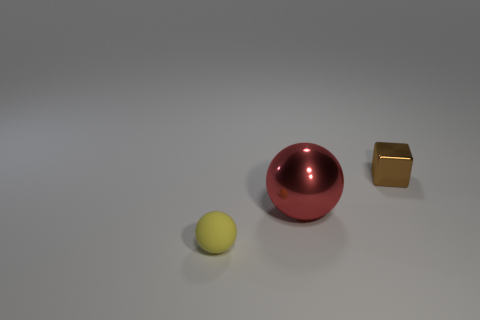Are there any shiny objects to the right of the sphere that is behind the tiny object in front of the red object?
Your response must be concise. Yes. What is the material of the large red object that is the same shape as the yellow thing?
Provide a short and direct response. Metal. There is a metallic thing that is right of the red thing; what color is it?
Provide a succinct answer. Brown. There is a red sphere; is it the same size as the object to the right of the big red shiny thing?
Make the answer very short. No. The small object to the left of the object that is on the right side of the ball to the right of the tiny yellow rubber thing is what color?
Your answer should be compact. Yellow. Is the material of the tiny thing that is behind the matte sphere the same as the tiny ball?
Offer a very short reply. No. There is a thing that is the same size as the yellow sphere; what material is it?
Your response must be concise. Metal. There is a thing that is behind the red sphere; is it the same shape as the tiny thing on the left side of the cube?
Give a very brief answer. No. There is a yellow rubber object that is the same size as the brown metallic cube; what shape is it?
Make the answer very short. Sphere. Is the small thing that is on the right side of the tiny matte sphere made of the same material as the object that is in front of the big sphere?
Give a very brief answer. No. 